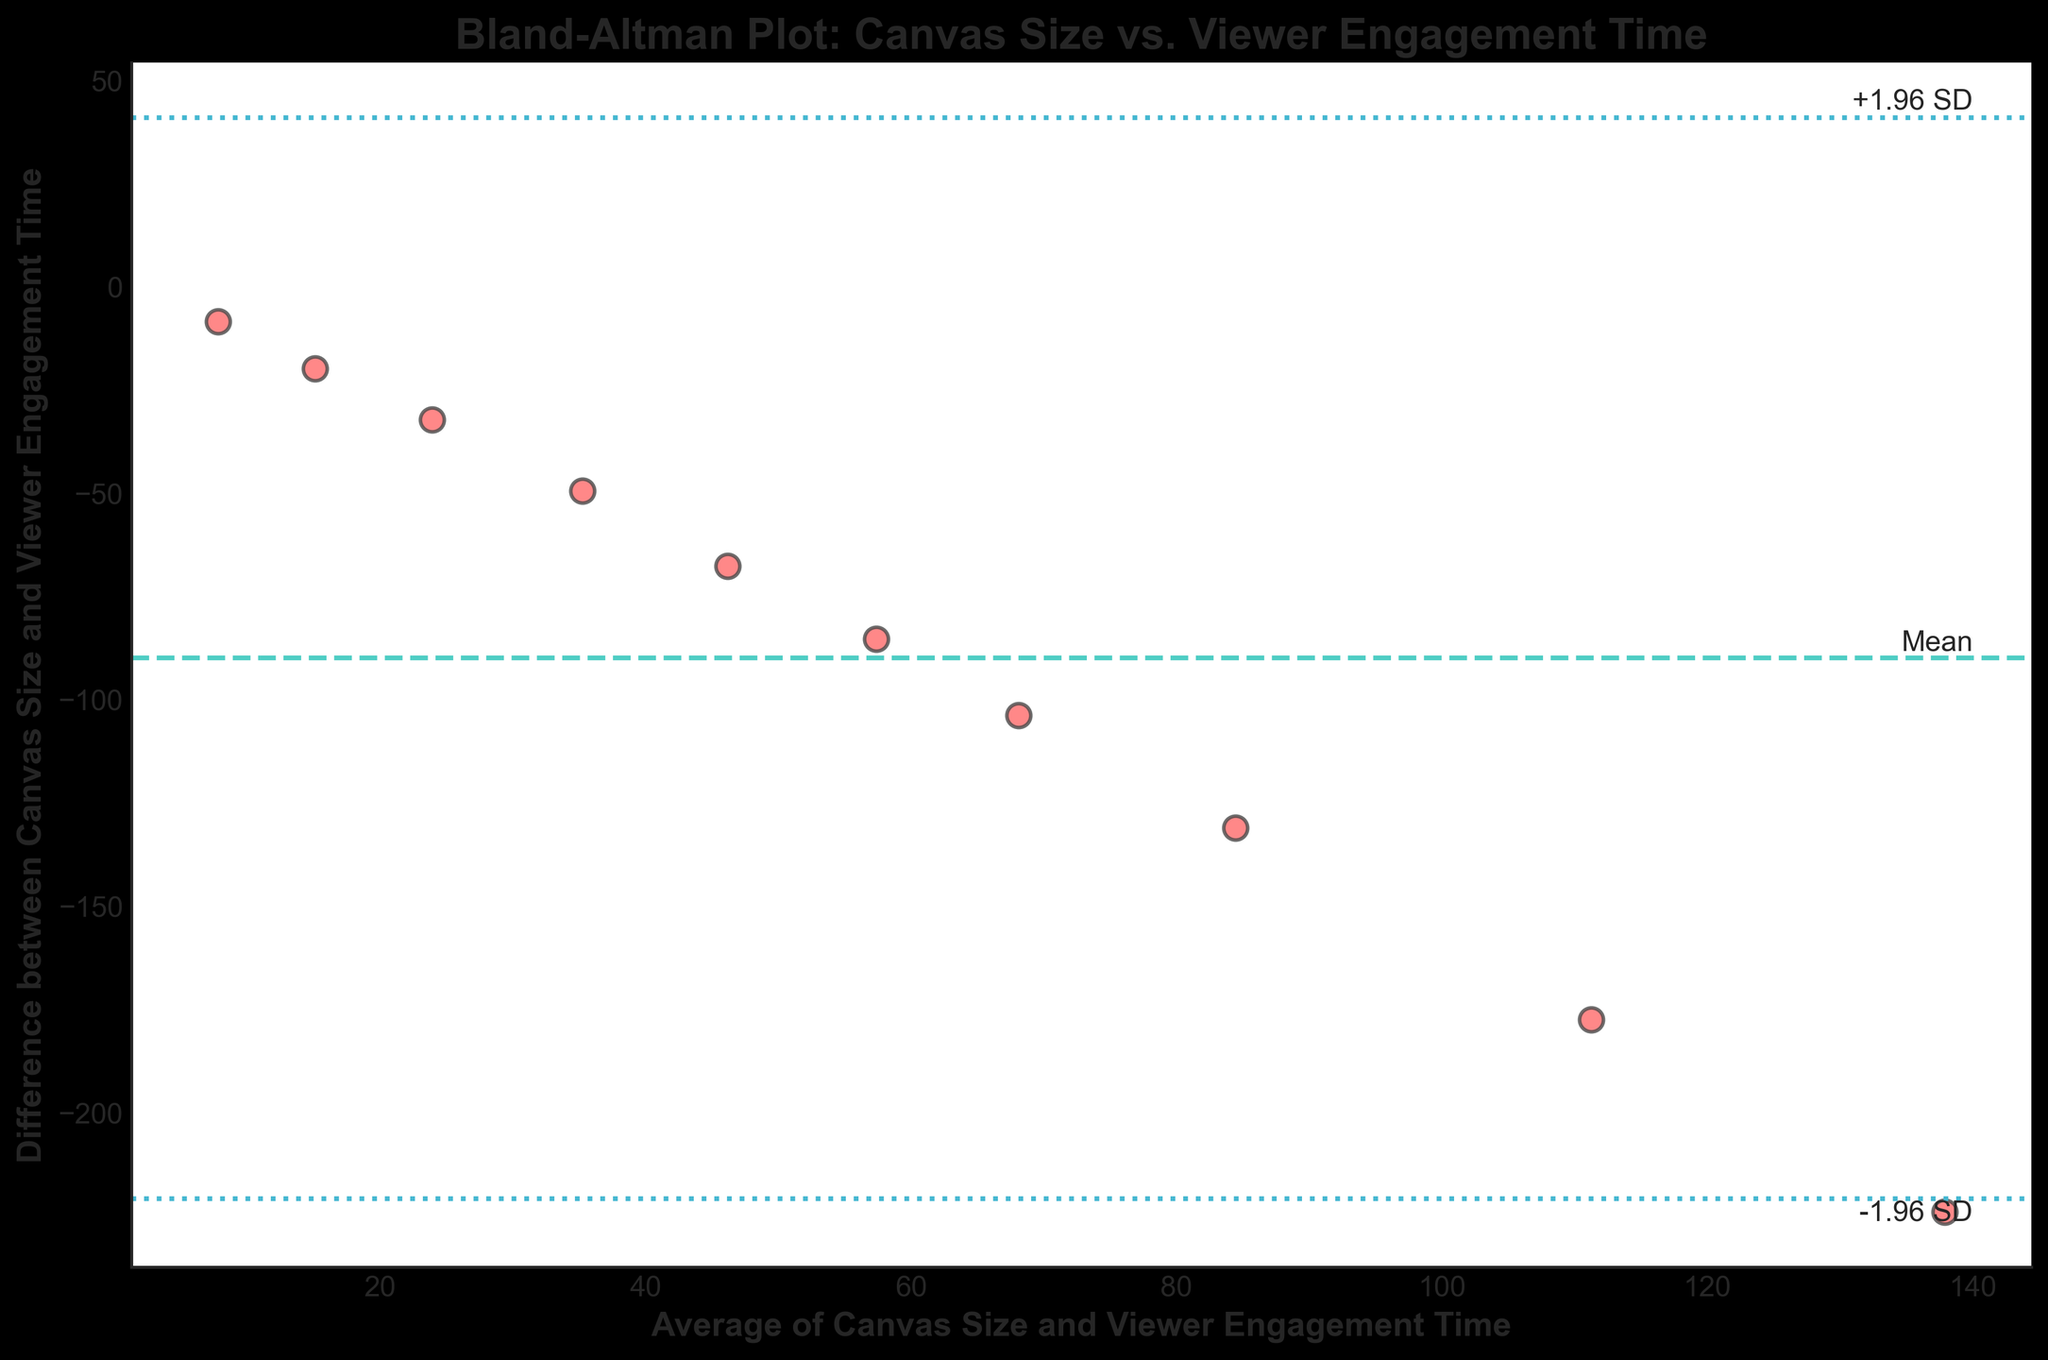What's the title of the plot? The title is clearly labeled at the top of the plot and provides a summary of the figure.
Answer: Bland-Altman Plot: Canvas Size vs. Viewer Engagement Time How many data points are plotted? Count the number of points scattered on the plot.
Answer: 10 What's the formula for the limits represented by the dashed lines? These lines are marked as Mean ± 1.96 * Standard Deviation, which is a standard deviation multiplier formula used in statistical analysis in a Bland–Altman plot.
Answer: Mean ± 1.96 SD What's the mean difference between the Canvas Size and Viewer Engagement Time? The mean difference value is graphically represented by the centrally located dashed line labeled as "Mean".
Answer: 2.63 Are there any data points outside the ±1.96 SD lines? To determine this, visually inspect if any points lie beyond the lines labeled with +1.96 SD and -1.96 SD.
Answer: No What is the standard deviation of the differences? The distance between the mean line and either ±1.96 SD lines can be used to calculate the standard deviation: sd = (line difference) / 1.96.
Answer: 3.19 What's the difference between Canvas Size and Viewer Engagement Time at the highest average? Identify the highest average point on the x-axis and find the corresponding difference on the y-axis.
Answer: -112.6 How does the average of Canvas Size and Viewer Engagement Time change as the canvas size increases? Observe the x-axis values and note their distribution trend.
Answer: It increases Which data point has the highest difference? Identify the data point that is farthest vertically from the mean line.
Answer: Average 7.75 (Difference -8.5) What's the visual theme/style used in the plot? Assess the overall appearance and style of the plot including colors, fonts, and design elements.
Answer: Seaborn white 